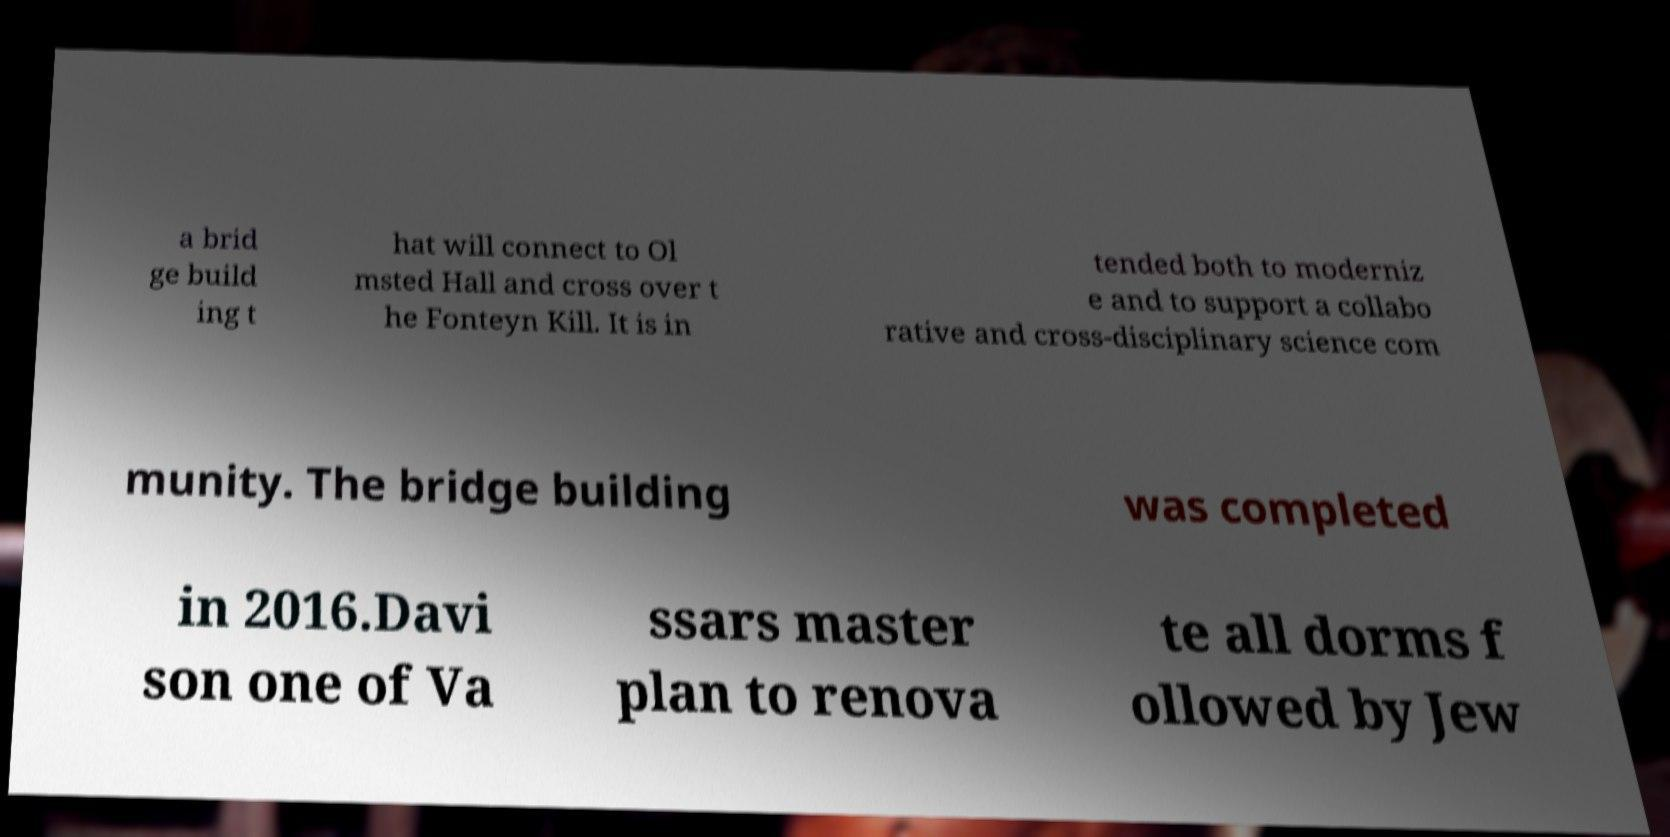What messages or text are displayed in this image? I need them in a readable, typed format. a brid ge build ing t hat will connect to Ol msted Hall and cross over t he Fonteyn Kill. It is in tended both to moderniz e and to support a collabo rative and cross-disciplinary science com munity. The bridge building was completed in 2016.Davi son one of Va ssars master plan to renova te all dorms f ollowed by Jew 